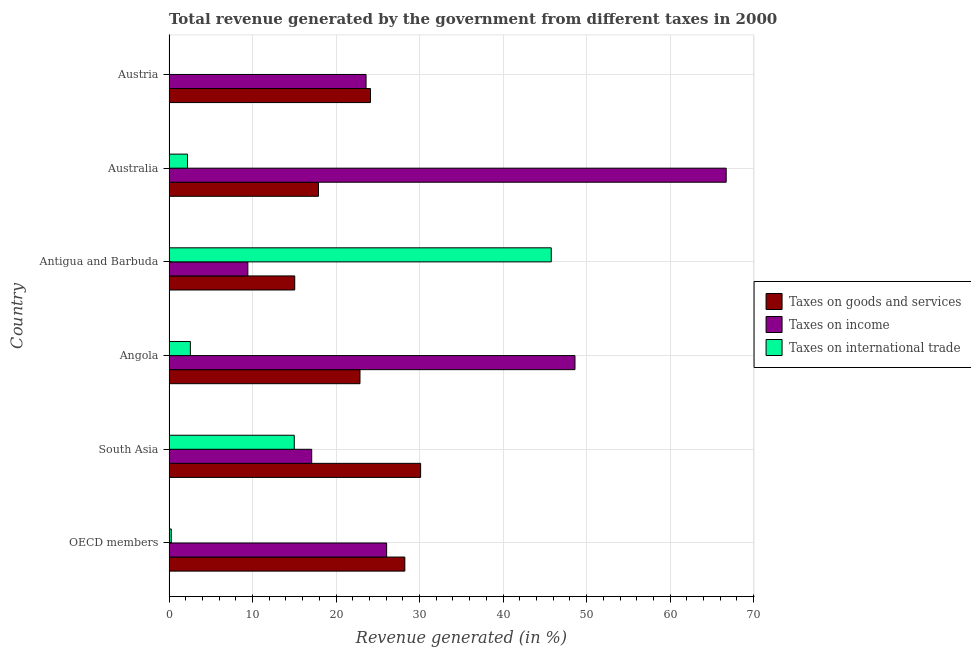How many different coloured bars are there?
Offer a terse response. 3. How many bars are there on the 5th tick from the bottom?
Make the answer very short. 3. What is the percentage of revenue generated by taxes on income in Angola?
Your response must be concise. 48.61. Across all countries, what is the maximum percentage of revenue generated by taxes on income?
Your answer should be very brief. 66.72. Across all countries, what is the minimum percentage of revenue generated by taxes on income?
Make the answer very short. 9.44. In which country was the percentage of revenue generated by taxes on income maximum?
Offer a terse response. Australia. What is the total percentage of revenue generated by tax on international trade in the graph?
Keep it short and to the point. 65.81. What is the difference between the percentage of revenue generated by taxes on goods and services in Antigua and Barbuda and that in South Asia?
Give a very brief answer. -15.07. What is the difference between the percentage of revenue generated by taxes on income in OECD members and the percentage of revenue generated by taxes on goods and services in Antigua and Barbuda?
Provide a short and direct response. 11. What is the average percentage of revenue generated by tax on international trade per country?
Give a very brief answer. 10.97. What is the difference between the percentage of revenue generated by tax on international trade and percentage of revenue generated by taxes on income in OECD members?
Your response must be concise. -25.79. What is the ratio of the percentage of revenue generated by taxes on income in Australia to that in OECD members?
Provide a short and direct response. 2.56. Is the difference between the percentage of revenue generated by taxes on income in Antigua and Barbuda and OECD members greater than the difference between the percentage of revenue generated by tax on international trade in Antigua and Barbuda and OECD members?
Your answer should be compact. No. What is the difference between the highest and the second highest percentage of revenue generated by tax on international trade?
Give a very brief answer. 30.77. What is the difference between the highest and the lowest percentage of revenue generated by taxes on income?
Keep it short and to the point. 57.27. In how many countries, is the percentage of revenue generated by tax on international trade greater than the average percentage of revenue generated by tax on international trade taken over all countries?
Your answer should be compact. 2. Is the sum of the percentage of revenue generated by taxes on goods and services in Australia and South Asia greater than the maximum percentage of revenue generated by tax on international trade across all countries?
Your response must be concise. Yes. Are all the bars in the graph horizontal?
Your answer should be very brief. Yes. How many countries are there in the graph?
Offer a very short reply. 6. What is the difference between two consecutive major ticks on the X-axis?
Offer a very short reply. 10. Are the values on the major ticks of X-axis written in scientific E-notation?
Provide a succinct answer. No. Does the graph contain any zero values?
Give a very brief answer. Yes. Does the graph contain grids?
Provide a short and direct response. Yes. How many legend labels are there?
Provide a succinct answer. 3. How are the legend labels stacked?
Offer a terse response. Vertical. What is the title of the graph?
Offer a terse response. Total revenue generated by the government from different taxes in 2000. Does "Interest" appear as one of the legend labels in the graph?
Offer a very short reply. No. What is the label or title of the X-axis?
Provide a succinct answer. Revenue generated (in %). What is the Revenue generated (in %) of Taxes on goods and services in OECD members?
Make the answer very short. 28.24. What is the Revenue generated (in %) in Taxes on income in OECD members?
Provide a succinct answer. 26.06. What is the Revenue generated (in %) of Taxes on international trade in OECD members?
Your response must be concise. 0.27. What is the Revenue generated (in %) in Taxes on goods and services in South Asia?
Keep it short and to the point. 30.13. What is the Revenue generated (in %) in Taxes on income in South Asia?
Keep it short and to the point. 17.09. What is the Revenue generated (in %) in Taxes on international trade in South Asia?
Offer a terse response. 15. What is the Revenue generated (in %) of Taxes on goods and services in Angola?
Provide a succinct answer. 22.87. What is the Revenue generated (in %) in Taxes on income in Angola?
Give a very brief answer. 48.61. What is the Revenue generated (in %) in Taxes on international trade in Angola?
Offer a very short reply. 2.56. What is the Revenue generated (in %) in Taxes on goods and services in Antigua and Barbuda?
Ensure brevity in your answer.  15.06. What is the Revenue generated (in %) of Taxes on income in Antigua and Barbuda?
Your response must be concise. 9.44. What is the Revenue generated (in %) of Taxes on international trade in Antigua and Barbuda?
Ensure brevity in your answer.  45.77. What is the Revenue generated (in %) of Taxes on goods and services in Australia?
Make the answer very short. 17.9. What is the Revenue generated (in %) in Taxes on income in Australia?
Your response must be concise. 66.72. What is the Revenue generated (in %) of Taxes on international trade in Australia?
Offer a terse response. 2.21. What is the Revenue generated (in %) of Taxes on goods and services in Austria?
Provide a succinct answer. 24.12. What is the Revenue generated (in %) of Taxes on income in Austria?
Provide a succinct answer. 23.59. Across all countries, what is the maximum Revenue generated (in %) in Taxes on goods and services?
Ensure brevity in your answer.  30.13. Across all countries, what is the maximum Revenue generated (in %) of Taxes on income?
Your answer should be compact. 66.72. Across all countries, what is the maximum Revenue generated (in %) of Taxes on international trade?
Your response must be concise. 45.77. Across all countries, what is the minimum Revenue generated (in %) of Taxes on goods and services?
Give a very brief answer. 15.06. Across all countries, what is the minimum Revenue generated (in %) in Taxes on income?
Your answer should be compact. 9.44. Across all countries, what is the minimum Revenue generated (in %) of Taxes on international trade?
Your response must be concise. 0. What is the total Revenue generated (in %) in Taxes on goods and services in the graph?
Your answer should be very brief. 138.31. What is the total Revenue generated (in %) of Taxes on income in the graph?
Provide a succinct answer. 191.51. What is the total Revenue generated (in %) in Taxes on international trade in the graph?
Give a very brief answer. 65.81. What is the difference between the Revenue generated (in %) of Taxes on goods and services in OECD members and that in South Asia?
Your answer should be compact. -1.89. What is the difference between the Revenue generated (in %) of Taxes on income in OECD members and that in South Asia?
Your answer should be compact. 8.97. What is the difference between the Revenue generated (in %) of Taxes on international trade in OECD members and that in South Asia?
Make the answer very short. -14.73. What is the difference between the Revenue generated (in %) of Taxes on goods and services in OECD members and that in Angola?
Give a very brief answer. 5.37. What is the difference between the Revenue generated (in %) in Taxes on income in OECD members and that in Angola?
Offer a very short reply. -22.55. What is the difference between the Revenue generated (in %) of Taxes on international trade in OECD members and that in Angola?
Ensure brevity in your answer.  -2.29. What is the difference between the Revenue generated (in %) of Taxes on goods and services in OECD members and that in Antigua and Barbuda?
Ensure brevity in your answer.  13.18. What is the difference between the Revenue generated (in %) in Taxes on income in OECD members and that in Antigua and Barbuda?
Give a very brief answer. 16.62. What is the difference between the Revenue generated (in %) in Taxes on international trade in OECD members and that in Antigua and Barbuda?
Your response must be concise. -45.5. What is the difference between the Revenue generated (in %) in Taxes on goods and services in OECD members and that in Australia?
Provide a short and direct response. 10.34. What is the difference between the Revenue generated (in %) in Taxes on income in OECD members and that in Australia?
Provide a succinct answer. -40.66. What is the difference between the Revenue generated (in %) of Taxes on international trade in OECD members and that in Australia?
Your response must be concise. -1.94. What is the difference between the Revenue generated (in %) of Taxes on goods and services in OECD members and that in Austria?
Your answer should be compact. 4.11. What is the difference between the Revenue generated (in %) of Taxes on income in OECD members and that in Austria?
Your answer should be compact. 2.46. What is the difference between the Revenue generated (in %) of Taxes on goods and services in South Asia and that in Angola?
Provide a succinct answer. 7.26. What is the difference between the Revenue generated (in %) in Taxes on income in South Asia and that in Angola?
Provide a short and direct response. -31.52. What is the difference between the Revenue generated (in %) in Taxes on international trade in South Asia and that in Angola?
Offer a very short reply. 12.44. What is the difference between the Revenue generated (in %) of Taxes on goods and services in South Asia and that in Antigua and Barbuda?
Provide a succinct answer. 15.07. What is the difference between the Revenue generated (in %) in Taxes on income in South Asia and that in Antigua and Barbuda?
Make the answer very short. 7.65. What is the difference between the Revenue generated (in %) of Taxes on international trade in South Asia and that in Antigua and Barbuda?
Your answer should be very brief. -30.77. What is the difference between the Revenue generated (in %) of Taxes on goods and services in South Asia and that in Australia?
Keep it short and to the point. 12.23. What is the difference between the Revenue generated (in %) in Taxes on income in South Asia and that in Australia?
Keep it short and to the point. -49.63. What is the difference between the Revenue generated (in %) of Taxes on international trade in South Asia and that in Australia?
Ensure brevity in your answer.  12.79. What is the difference between the Revenue generated (in %) of Taxes on goods and services in South Asia and that in Austria?
Your answer should be very brief. 6.01. What is the difference between the Revenue generated (in %) of Taxes on income in South Asia and that in Austria?
Ensure brevity in your answer.  -6.51. What is the difference between the Revenue generated (in %) in Taxes on goods and services in Angola and that in Antigua and Barbuda?
Make the answer very short. 7.81. What is the difference between the Revenue generated (in %) of Taxes on income in Angola and that in Antigua and Barbuda?
Give a very brief answer. 39.17. What is the difference between the Revenue generated (in %) of Taxes on international trade in Angola and that in Antigua and Barbuda?
Ensure brevity in your answer.  -43.21. What is the difference between the Revenue generated (in %) of Taxes on goods and services in Angola and that in Australia?
Provide a short and direct response. 4.97. What is the difference between the Revenue generated (in %) in Taxes on income in Angola and that in Australia?
Offer a very short reply. -18.11. What is the difference between the Revenue generated (in %) of Taxes on international trade in Angola and that in Australia?
Your response must be concise. 0.34. What is the difference between the Revenue generated (in %) of Taxes on goods and services in Angola and that in Austria?
Keep it short and to the point. -1.25. What is the difference between the Revenue generated (in %) of Taxes on income in Angola and that in Austria?
Provide a short and direct response. 25.02. What is the difference between the Revenue generated (in %) in Taxes on goods and services in Antigua and Barbuda and that in Australia?
Offer a terse response. -2.84. What is the difference between the Revenue generated (in %) in Taxes on income in Antigua and Barbuda and that in Australia?
Provide a succinct answer. -57.27. What is the difference between the Revenue generated (in %) in Taxes on international trade in Antigua and Barbuda and that in Australia?
Make the answer very short. 43.56. What is the difference between the Revenue generated (in %) of Taxes on goods and services in Antigua and Barbuda and that in Austria?
Give a very brief answer. -9.07. What is the difference between the Revenue generated (in %) of Taxes on income in Antigua and Barbuda and that in Austria?
Offer a terse response. -14.15. What is the difference between the Revenue generated (in %) of Taxes on goods and services in Australia and that in Austria?
Keep it short and to the point. -6.22. What is the difference between the Revenue generated (in %) in Taxes on income in Australia and that in Austria?
Your answer should be compact. 43.12. What is the difference between the Revenue generated (in %) in Taxes on goods and services in OECD members and the Revenue generated (in %) in Taxes on income in South Asia?
Make the answer very short. 11.15. What is the difference between the Revenue generated (in %) of Taxes on goods and services in OECD members and the Revenue generated (in %) of Taxes on international trade in South Asia?
Offer a terse response. 13.24. What is the difference between the Revenue generated (in %) of Taxes on income in OECD members and the Revenue generated (in %) of Taxes on international trade in South Asia?
Offer a terse response. 11.06. What is the difference between the Revenue generated (in %) of Taxes on goods and services in OECD members and the Revenue generated (in %) of Taxes on income in Angola?
Make the answer very short. -20.37. What is the difference between the Revenue generated (in %) of Taxes on goods and services in OECD members and the Revenue generated (in %) of Taxes on international trade in Angola?
Your answer should be very brief. 25.68. What is the difference between the Revenue generated (in %) of Taxes on income in OECD members and the Revenue generated (in %) of Taxes on international trade in Angola?
Offer a very short reply. 23.5. What is the difference between the Revenue generated (in %) of Taxes on goods and services in OECD members and the Revenue generated (in %) of Taxes on income in Antigua and Barbuda?
Offer a terse response. 18.8. What is the difference between the Revenue generated (in %) in Taxes on goods and services in OECD members and the Revenue generated (in %) in Taxes on international trade in Antigua and Barbuda?
Offer a very short reply. -17.53. What is the difference between the Revenue generated (in %) in Taxes on income in OECD members and the Revenue generated (in %) in Taxes on international trade in Antigua and Barbuda?
Give a very brief answer. -19.71. What is the difference between the Revenue generated (in %) of Taxes on goods and services in OECD members and the Revenue generated (in %) of Taxes on income in Australia?
Provide a succinct answer. -38.48. What is the difference between the Revenue generated (in %) in Taxes on goods and services in OECD members and the Revenue generated (in %) in Taxes on international trade in Australia?
Your answer should be compact. 26.02. What is the difference between the Revenue generated (in %) of Taxes on income in OECD members and the Revenue generated (in %) of Taxes on international trade in Australia?
Provide a succinct answer. 23.85. What is the difference between the Revenue generated (in %) in Taxes on goods and services in OECD members and the Revenue generated (in %) in Taxes on income in Austria?
Ensure brevity in your answer.  4.64. What is the difference between the Revenue generated (in %) of Taxes on goods and services in South Asia and the Revenue generated (in %) of Taxes on income in Angola?
Provide a short and direct response. -18.48. What is the difference between the Revenue generated (in %) of Taxes on goods and services in South Asia and the Revenue generated (in %) of Taxes on international trade in Angola?
Keep it short and to the point. 27.57. What is the difference between the Revenue generated (in %) in Taxes on income in South Asia and the Revenue generated (in %) in Taxes on international trade in Angola?
Keep it short and to the point. 14.53. What is the difference between the Revenue generated (in %) of Taxes on goods and services in South Asia and the Revenue generated (in %) of Taxes on income in Antigua and Barbuda?
Your answer should be very brief. 20.69. What is the difference between the Revenue generated (in %) of Taxes on goods and services in South Asia and the Revenue generated (in %) of Taxes on international trade in Antigua and Barbuda?
Provide a short and direct response. -15.64. What is the difference between the Revenue generated (in %) in Taxes on income in South Asia and the Revenue generated (in %) in Taxes on international trade in Antigua and Barbuda?
Provide a short and direct response. -28.68. What is the difference between the Revenue generated (in %) of Taxes on goods and services in South Asia and the Revenue generated (in %) of Taxes on income in Australia?
Provide a succinct answer. -36.59. What is the difference between the Revenue generated (in %) in Taxes on goods and services in South Asia and the Revenue generated (in %) in Taxes on international trade in Australia?
Offer a terse response. 27.91. What is the difference between the Revenue generated (in %) in Taxes on income in South Asia and the Revenue generated (in %) in Taxes on international trade in Australia?
Provide a short and direct response. 14.87. What is the difference between the Revenue generated (in %) in Taxes on goods and services in South Asia and the Revenue generated (in %) in Taxes on income in Austria?
Your answer should be compact. 6.53. What is the difference between the Revenue generated (in %) in Taxes on goods and services in Angola and the Revenue generated (in %) in Taxes on income in Antigua and Barbuda?
Your answer should be very brief. 13.43. What is the difference between the Revenue generated (in %) in Taxes on goods and services in Angola and the Revenue generated (in %) in Taxes on international trade in Antigua and Barbuda?
Offer a very short reply. -22.9. What is the difference between the Revenue generated (in %) of Taxes on income in Angola and the Revenue generated (in %) of Taxes on international trade in Antigua and Barbuda?
Ensure brevity in your answer.  2.84. What is the difference between the Revenue generated (in %) in Taxes on goods and services in Angola and the Revenue generated (in %) in Taxes on income in Australia?
Give a very brief answer. -43.85. What is the difference between the Revenue generated (in %) of Taxes on goods and services in Angola and the Revenue generated (in %) of Taxes on international trade in Australia?
Provide a succinct answer. 20.65. What is the difference between the Revenue generated (in %) in Taxes on income in Angola and the Revenue generated (in %) in Taxes on international trade in Australia?
Provide a succinct answer. 46.4. What is the difference between the Revenue generated (in %) in Taxes on goods and services in Angola and the Revenue generated (in %) in Taxes on income in Austria?
Offer a very short reply. -0.73. What is the difference between the Revenue generated (in %) in Taxes on goods and services in Antigua and Barbuda and the Revenue generated (in %) in Taxes on income in Australia?
Your answer should be compact. -51.66. What is the difference between the Revenue generated (in %) in Taxes on goods and services in Antigua and Barbuda and the Revenue generated (in %) in Taxes on international trade in Australia?
Your answer should be compact. 12.84. What is the difference between the Revenue generated (in %) of Taxes on income in Antigua and Barbuda and the Revenue generated (in %) of Taxes on international trade in Australia?
Give a very brief answer. 7.23. What is the difference between the Revenue generated (in %) of Taxes on goods and services in Antigua and Barbuda and the Revenue generated (in %) of Taxes on income in Austria?
Keep it short and to the point. -8.54. What is the difference between the Revenue generated (in %) in Taxes on goods and services in Australia and the Revenue generated (in %) in Taxes on income in Austria?
Ensure brevity in your answer.  -5.69. What is the average Revenue generated (in %) of Taxes on goods and services per country?
Your response must be concise. 23.05. What is the average Revenue generated (in %) in Taxes on income per country?
Your answer should be very brief. 31.92. What is the average Revenue generated (in %) in Taxes on international trade per country?
Provide a short and direct response. 10.97. What is the difference between the Revenue generated (in %) in Taxes on goods and services and Revenue generated (in %) in Taxes on income in OECD members?
Offer a very short reply. 2.18. What is the difference between the Revenue generated (in %) in Taxes on goods and services and Revenue generated (in %) in Taxes on international trade in OECD members?
Provide a succinct answer. 27.97. What is the difference between the Revenue generated (in %) in Taxes on income and Revenue generated (in %) in Taxes on international trade in OECD members?
Keep it short and to the point. 25.79. What is the difference between the Revenue generated (in %) in Taxes on goods and services and Revenue generated (in %) in Taxes on income in South Asia?
Provide a succinct answer. 13.04. What is the difference between the Revenue generated (in %) of Taxes on goods and services and Revenue generated (in %) of Taxes on international trade in South Asia?
Your response must be concise. 15.13. What is the difference between the Revenue generated (in %) in Taxes on income and Revenue generated (in %) in Taxes on international trade in South Asia?
Your answer should be compact. 2.09. What is the difference between the Revenue generated (in %) of Taxes on goods and services and Revenue generated (in %) of Taxes on income in Angola?
Make the answer very short. -25.74. What is the difference between the Revenue generated (in %) in Taxes on goods and services and Revenue generated (in %) in Taxes on international trade in Angola?
Provide a short and direct response. 20.31. What is the difference between the Revenue generated (in %) of Taxes on income and Revenue generated (in %) of Taxes on international trade in Angola?
Make the answer very short. 46.05. What is the difference between the Revenue generated (in %) of Taxes on goods and services and Revenue generated (in %) of Taxes on income in Antigua and Barbuda?
Give a very brief answer. 5.61. What is the difference between the Revenue generated (in %) in Taxes on goods and services and Revenue generated (in %) in Taxes on international trade in Antigua and Barbuda?
Make the answer very short. -30.71. What is the difference between the Revenue generated (in %) in Taxes on income and Revenue generated (in %) in Taxes on international trade in Antigua and Barbuda?
Your response must be concise. -36.33. What is the difference between the Revenue generated (in %) of Taxes on goods and services and Revenue generated (in %) of Taxes on income in Australia?
Make the answer very short. -48.82. What is the difference between the Revenue generated (in %) in Taxes on goods and services and Revenue generated (in %) in Taxes on international trade in Australia?
Offer a very short reply. 15.69. What is the difference between the Revenue generated (in %) in Taxes on income and Revenue generated (in %) in Taxes on international trade in Australia?
Your answer should be compact. 64.5. What is the difference between the Revenue generated (in %) in Taxes on goods and services and Revenue generated (in %) in Taxes on income in Austria?
Make the answer very short. 0.53. What is the ratio of the Revenue generated (in %) in Taxes on goods and services in OECD members to that in South Asia?
Your response must be concise. 0.94. What is the ratio of the Revenue generated (in %) of Taxes on income in OECD members to that in South Asia?
Ensure brevity in your answer.  1.53. What is the ratio of the Revenue generated (in %) of Taxes on international trade in OECD members to that in South Asia?
Ensure brevity in your answer.  0.02. What is the ratio of the Revenue generated (in %) in Taxes on goods and services in OECD members to that in Angola?
Offer a terse response. 1.23. What is the ratio of the Revenue generated (in %) of Taxes on income in OECD members to that in Angola?
Give a very brief answer. 0.54. What is the ratio of the Revenue generated (in %) in Taxes on international trade in OECD members to that in Angola?
Provide a succinct answer. 0.11. What is the ratio of the Revenue generated (in %) in Taxes on goods and services in OECD members to that in Antigua and Barbuda?
Provide a short and direct response. 1.88. What is the ratio of the Revenue generated (in %) in Taxes on income in OECD members to that in Antigua and Barbuda?
Provide a succinct answer. 2.76. What is the ratio of the Revenue generated (in %) of Taxes on international trade in OECD members to that in Antigua and Barbuda?
Ensure brevity in your answer.  0.01. What is the ratio of the Revenue generated (in %) of Taxes on goods and services in OECD members to that in Australia?
Offer a terse response. 1.58. What is the ratio of the Revenue generated (in %) in Taxes on income in OECD members to that in Australia?
Provide a short and direct response. 0.39. What is the ratio of the Revenue generated (in %) of Taxes on international trade in OECD members to that in Australia?
Keep it short and to the point. 0.12. What is the ratio of the Revenue generated (in %) in Taxes on goods and services in OECD members to that in Austria?
Your answer should be compact. 1.17. What is the ratio of the Revenue generated (in %) in Taxes on income in OECD members to that in Austria?
Provide a succinct answer. 1.1. What is the ratio of the Revenue generated (in %) of Taxes on goods and services in South Asia to that in Angola?
Make the answer very short. 1.32. What is the ratio of the Revenue generated (in %) of Taxes on income in South Asia to that in Angola?
Ensure brevity in your answer.  0.35. What is the ratio of the Revenue generated (in %) in Taxes on international trade in South Asia to that in Angola?
Your answer should be compact. 5.86. What is the ratio of the Revenue generated (in %) of Taxes on goods and services in South Asia to that in Antigua and Barbuda?
Keep it short and to the point. 2. What is the ratio of the Revenue generated (in %) in Taxes on income in South Asia to that in Antigua and Barbuda?
Provide a short and direct response. 1.81. What is the ratio of the Revenue generated (in %) of Taxes on international trade in South Asia to that in Antigua and Barbuda?
Give a very brief answer. 0.33. What is the ratio of the Revenue generated (in %) of Taxes on goods and services in South Asia to that in Australia?
Offer a very short reply. 1.68. What is the ratio of the Revenue generated (in %) in Taxes on income in South Asia to that in Australia?
Keep it short and to the point. 0.26. What is the ratio of the Revenue generated (in %) of Taxes on international trade in South Asia to that in Australia?
Provide a succinct answer. 6.78. What is the ratio of the Revenue generated (in %) of Taxes on goods and services in South Asia to that in Austria?
Ensure brevity in your answer.  1.25. What is the ratio of the Revenue generated (in %) in Taxes on income in South Asia to that in Austria?
Make the answer very short. 0.72. What is the ratio of the Revenue generated (in %) in Taxes on goods and services in Angola to that in Antigua and Barbuda?
Your answer should be very brief. 1.52. What is the ratio of the Revenue generated (in %) in Taxes on income in Angola to that in Antigua and Barbuda?
Offer a terse response. 5.15. What is the ratio of the Revenue generated (in %) in Taxes on international trade in Angola to that in Antigua and Barbuda?
Your answer should be very brief. 0.06. What is the ratio of the Revenue generated (in %) of Taxes on goods and services in Angola to that in Australia?
Your answer should be very brief. 1.28. What is the ratio of the Revenue generated (in %) in Taxes on income in Angola to that in Australia?
Your answer should be compact. 0.73. What is the ratio of the Revenue generated (in %) in Taxes on international trade in Angola to that in Australia?
Your answer should be compact. 1.16. What is the ratio of the Revenue generated (in %) of Taxes on goods and services in Angola to that in Austria?
Make the answer very short. 0.95. What is the ratio of the Revenue generated (in %) of Taxes on income in Angola to that in Austria?
Your response must be concise. 2.06. What is the ratio of the Revenue generated (in %) of Taxes on goods and services in Antigua and Barbuda to that in Australia?
Your answer should be compact. 0.84. What is the ratio of the Revenue generated (in %) of Taxes on income in Antigua and Barbuda to that in Australia?
Keep it short and to the point. 0.14. What is the ratio of the Revenue generated (in %) of Taxes on international trade in Antigua and Barbuda to that in Australia?
Provide a short and direct response. 20.68. What is the ratio of the Revenue generated (in %) of Taxes on goods and services in Antigua and Barbuda to that in Austria?
Your answer should be compact. 0.62. What is the ratio of the Revenue generated (in %) of Taxes on income in Antigua and Barbuda to that in Austria?
Provide a succinct answer. 0.4. What is the ratio of the Revenue generated (in %) in Taxes on goods and services in Australia to that in Austria?
Provide a short and direct response. 0.74. What is the ratio of the Revenue generated (in %) in Taxes on income in Australia to that in Austria?
Provide a succinct answer. 2.83. What is the difference between the highest and the second highest Revenue generated (in %) of Taxes on goods and services?
Your answer should be compact. 1.89. What is the difference between the highest and the second highest Revenue generated (in %) in Taxes on income?
Make the answer very short. 18.11. What is the difference between the highest and the second highest Revenue generated (in %) in Taxes on international trade?
Offer a terse response. 30.77. What is the difference between the highest and the lowest Revenue generated (in %) in Taxes on goods and services?
Make the answer very short. 15.07. What is the difference between the highest and the lowest Revenue generated (in %) of Taxes on income?
Your answer should be very brief. 57.27. What is the difference between the highest and the lowest Revenue generated (in %) in Taxes on international trade?
Ensure brevity in your answer.  45.77. 